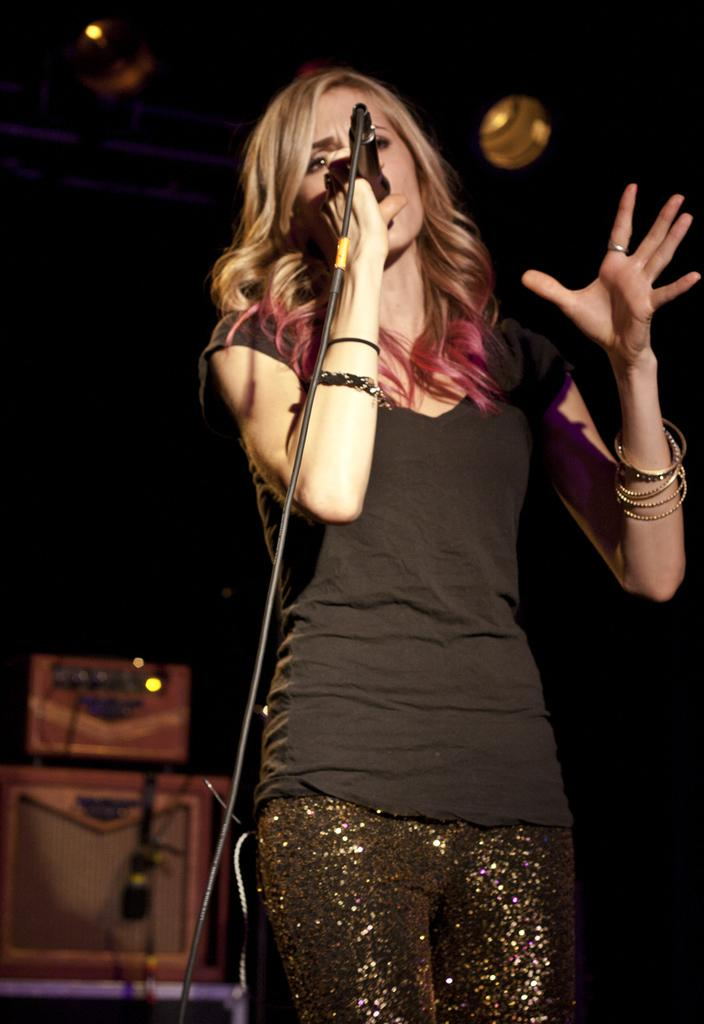Who is the main subject in the image? There is a woman in the image. What is the woman doing in the image? The woman is standing and singing a song. What is the woman holding in the image? The woman is holding a microphone. What can be seen in the background of the image? There is a cardboard box in the background of the image. What is the rate of the water flowing from the basin in the image? There is no basin or water present in the image. How does the key help the woman in the image? There is no key mentioned in the image; the woman is holding a microphone while singing. 